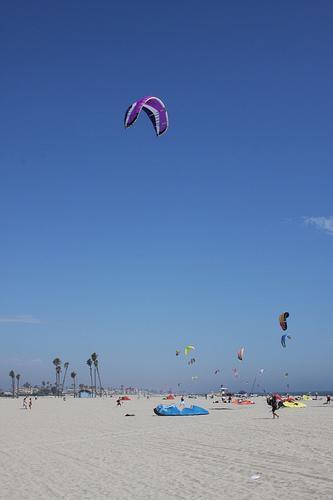What type of weather is the beach seeing today?
Choose the right answer and clarify with the format: 'Answer: answer
Rationale: rationale.'
Options: Hurricane, snow, wind, rain. Answer: wind.
Rationale: Kites need wind. 